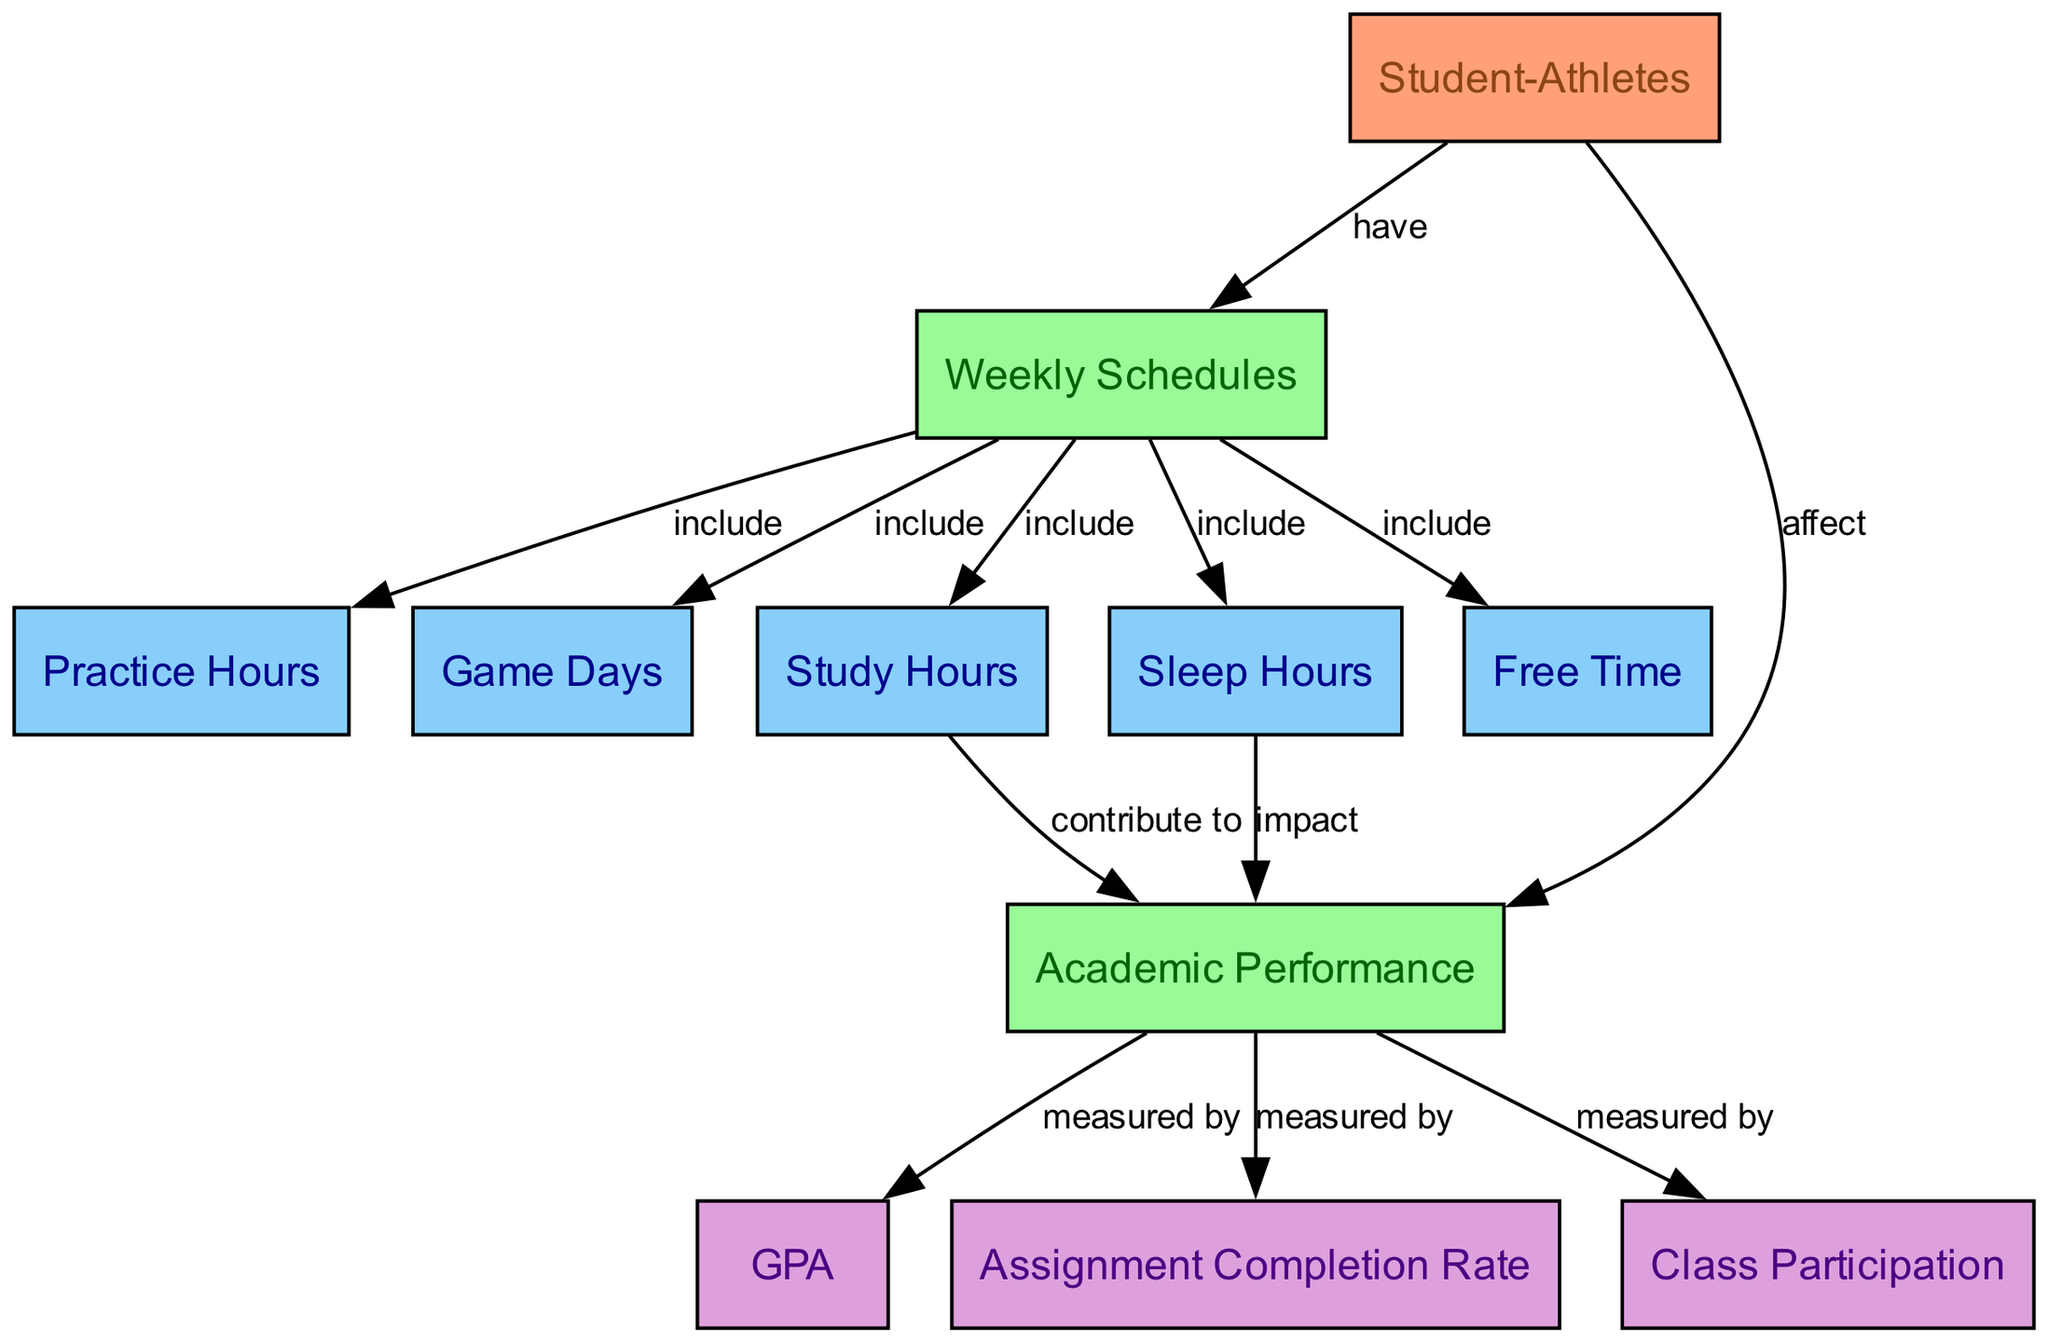What is the total number of nodes in the diagram? To find the total number of nodes, we can count each unique entry in the "nodes" section of the data provided. There are 11 distinct nodes listed.
Answer: 11 Which node represents academic performance? The node that refers to academic performance is labeled "Academic Performance" and has the ID "A8". This can be identified by locating the label among the nodes.
Answer: Academic Performance How many edges connect to the "Student-Athletes" node? We can determine the number of edges connected to the "Student-Athletes" node by counting how many times it appears as a 'from' location in the edges section. "Student-Athletes" appears twice as a starting point for edges.
Answer: 2 What do "Study Hours" contribute to? "Study Hours," represented by the node with ID "A5," is connected to "Academic Performance" with the label "contribute to." This indicates that study hours have an impact on academic performance.
Answer: Academic Performance What is the relationship between "Sleep Hours" and academic performance? The relationship is indicated by an edge from "Sleep Hours" (A6) to "Academic Performance" (A8), labeled "impact." This means that sleep hours directly affect academic performance.
Answer: impact How many metrics measure academic performance? By reviewing the edges leading from the "Academic Performance" node (A8), we see there are three connections that measure academic performance: GPA, Assignment Completion Rate, and Class Participation. Therefore, there are three metrics.
Answer: 3 What do "Weekly Schedules" include besides practice hours and game days? The "Weekly Schedules" node (A2) connects to several nodes: "Practice Hours," "Game Days," "Study Hours," "Sleep Hours," and "Free Time." Hence, aside from "Practice Hours" and "Game Days," it includes "Study Hours," "Sleep Hours," and "Free Time."
Answer: Study Hours, Sleep Hours, Free Time Which node is impacted by both practice hours and study hours? Upon examining the edges, "Academic Performance" (A8) is impacted by both "Practice Hours" (A3) as part of the "Weekly Schedules" and directly by "Study Hours" (A5) through the labeled edges.
Answer: Academic Performance How many types of academic performance metrics are displayed in the diagram? The metrics for academic performance are listed as GPA, Assignment Completion Rate, and Class Participation, which are connected to the "Academic Performance" node. This totals three distinct types.
Answer: 3 